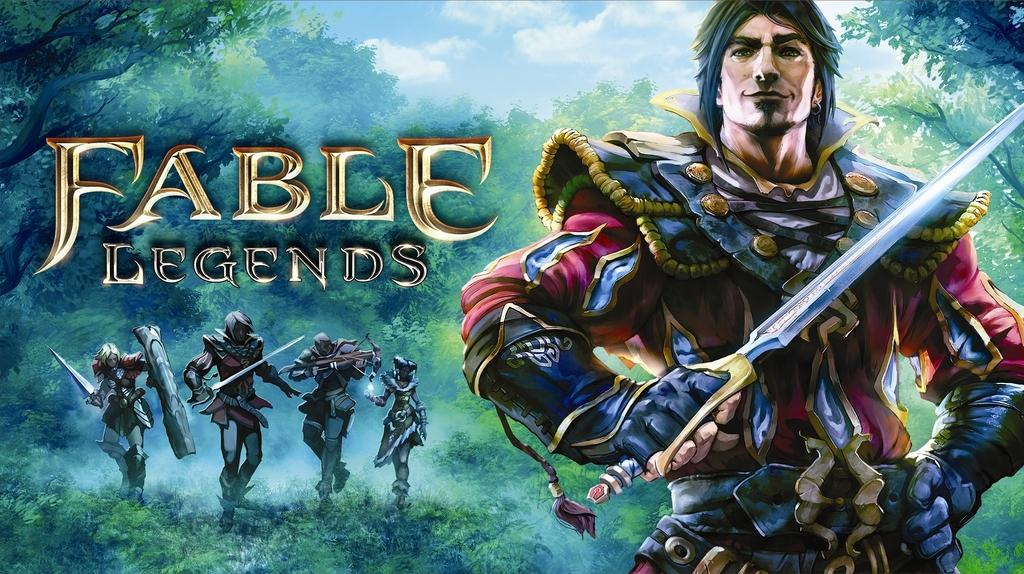<image>
Offer a succinct explanation of the picture presented. Fable legends advertisement showing man holding a sword with four monsters in the background in a forest. 